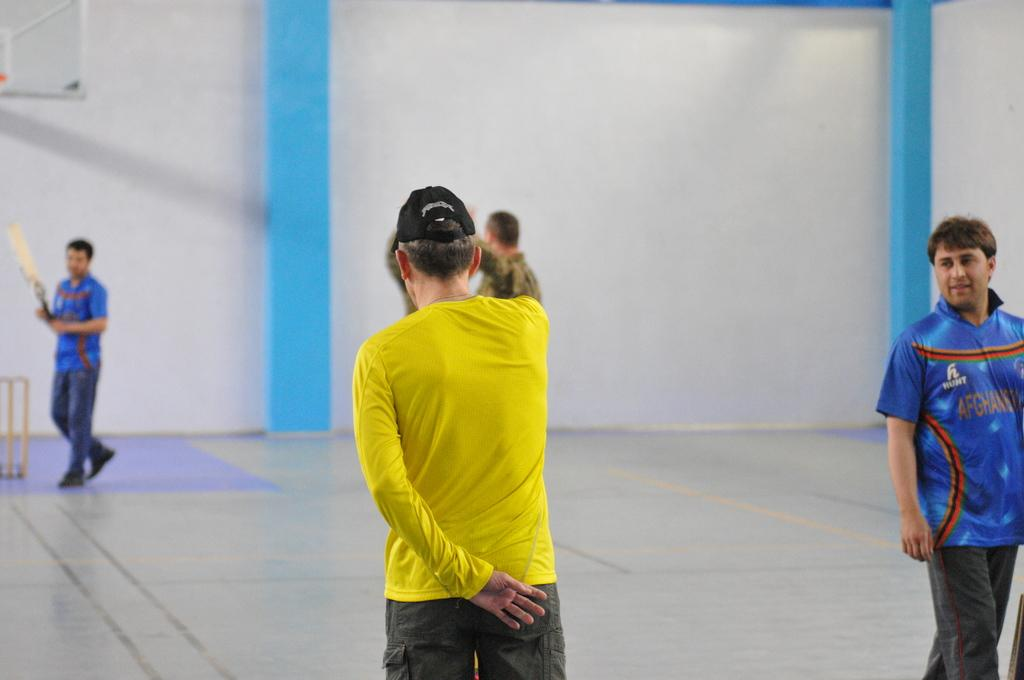<image>
Summarize the visual content of the image. a person in a yellow shirt next to a man in a blue Afghanistan shirt 